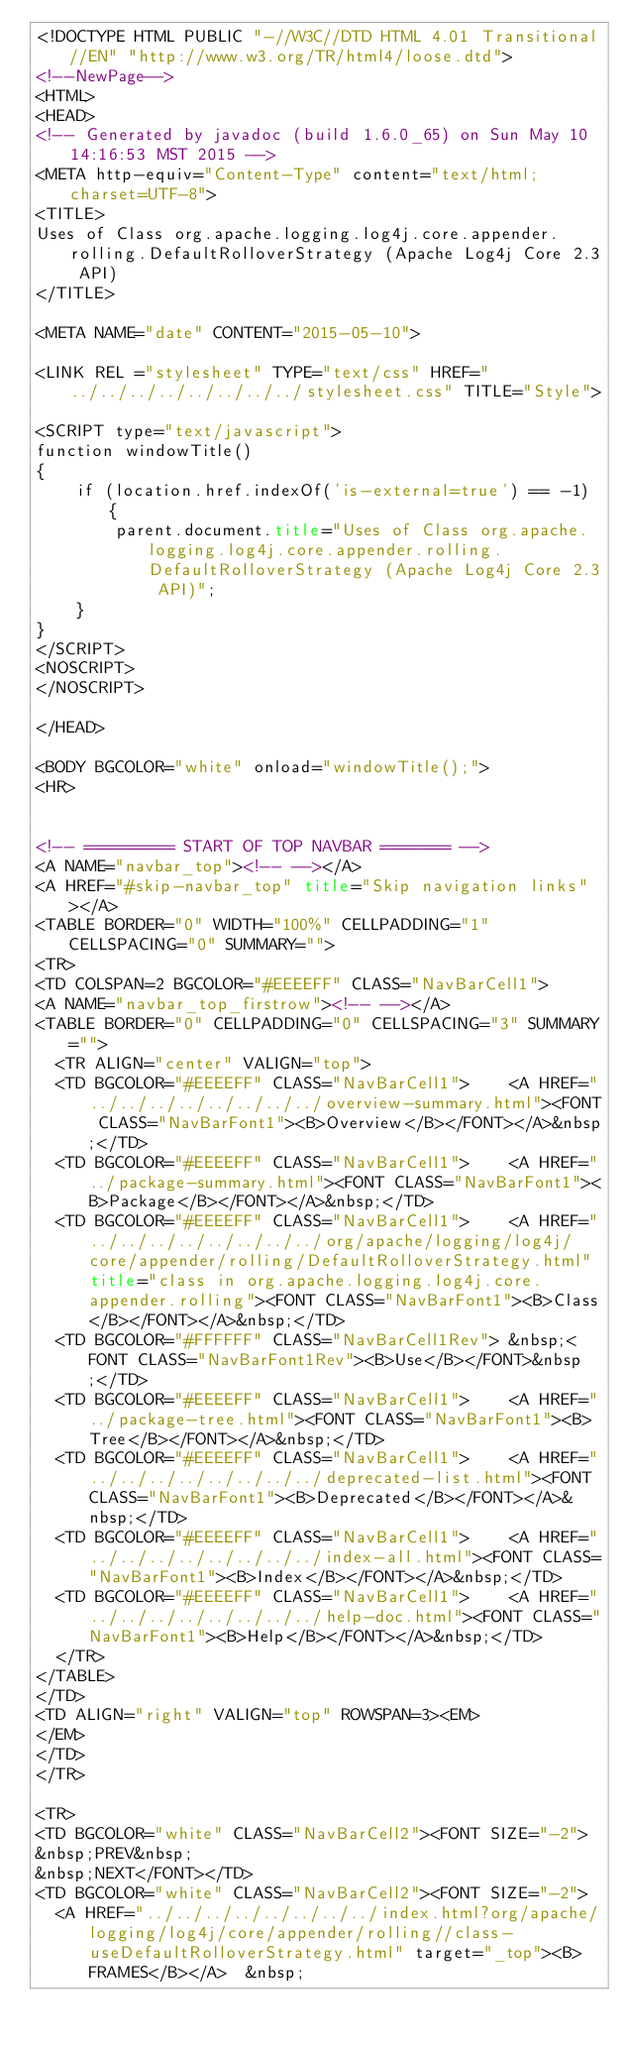<code> <loc_0><loc_0><loc_500><loc_500><_HTML_><!DOCTYPE HTML PUBLIC "-//W3C//DTD HTML 4.01 Transitional//EN" "http://www.w3.org/TR/html4/loose.dtd">
<!--NewPage-->
<HTML>
<HEAD>
<!-- Generated by javadoc (build 1.6.0_65) on Sun May 10 14:16:53 MST 2015 -->
<META http-equiv="Content-Type" content="text/html; charset=UTF-8">
<TITLE>
Uses of Class org.apache.logging.log4j.core.appender.rolling.DefaultRolloverStrategy (Apache Log4j Core 2.3 API)
</TITLE>

<META NAME="date" CONTENT="2015-05-10">

<LINK REL ="stylesheet" TYPE="text/css" HREF="../../../../../../../../stylesheet.css" TITLE="Style">

<SCRIPT type="text/javascript">
function windowTitle()
{
    if (location.href.indexOf('is-external=true') == -1) {
        parent.document.title="Uses of Class org.apache.logging.log4j.core.appender.rolling.DefaultRolloverStrategy (Apache Log4j Core 2.3 API)";
    }
}
</SCRIPT>
<NOSCRIPT>
</NOSCRIPT>

</HEAD>

<BODY BGCOLOR="white" onload="windowTitle();">
<HR>


<!-- ========= START OF TOP NAVBAR ======= -->
<A NAME="navbar_top"><!-- --></A>
<A HREF="#skip-navbar_top" title="Skip navigation links"></A>
<TABLE BORDER="0" WIDTH="100%" CELLPADDING="1" CELLSPACING="0" SUMMARY="">
<TR>
<TD COLSPAN=2 BGCOLOR="#EEEEFF" CLASS="NavBarCell1">
<A NAME="navbar_top_firstrow"><!-- --></A>
<TABLE BORDER="0" CELLPADDING="0" CELLSPACING="3" SUMMARY="">
  <TR ALIGN="center" VALIGN="top">
  <TD BGCOLOR="#EEEEFF" CLASS="NavBarCell1">    <A HREF="../../../../../../../../overview-summary.html"><FONT CLASS="NavBarFont1"><B>Overview</B></FONT></A>&nbsp;</TD>
  <TD BGCOLOR="#EEEEFF" CLASS="NavBarCell1">    <A HREF="../package-summary.html"><FONT CLASS="NavBarFont1"><B>Package</B></FONT></A>&nbsp;</TD>
  <TD BGCOLOR="#EEEEFF" CLASS="NavBarCell1">    <A HREF="../../../../../../../../org/apache/logging/log4j/core/appender/rolling/DefaultRolloverStrategy.html" title="class in org.apache.logging.log4j.core.appender.rolling"><FONT CLASS="NavBarFont1"><B>Class</B></FONT></A>&nbsp;</TD>
  <TD BGCOLOR="#FFFFFF" CLASS="NavBarCell1Rev"> &nbsp;<FONT CLASS="NavBarFont1Rev"><B>Use</B></FONT>&nbsp;</TD>
  <TD BGCOLOR="#EEEEFF" CLASS="NavBarCell1">    <A HREF="../package-tree.html"><FONT CLASS="NavBarFont1"><B>Tree</B></FONT></A>&nbsp;</TD>
  <TD BGCOLOR="#EEEEFF" CLASS="NavBarCell1">    <A HREF="../../../../../../../../deprecated-list.html"><FONT CLASS="NavBarFont1"><B>Deprecated</B></FONT></A>&nbsp;</TD>
  <TD BGCOLOR="#EEEEFF" CLASS="NavBarCell1">    <A HREF="../../../../../../../../index-all.html"><FONT CLASS="NavBarFont1"><B>Index</B></FONT></A>&nbsp;</TD>
  <TD BGCOLOR="#EEEEFF" CLASS="NavBarCell1">    <A HREF="../../../../../../../../help-doc.html"><FONT CLASS="NavBarFont1"><B>Help</B></FONT></A>&nbsp;</TD>
  </TR>
</TABLE>
</TD>
<TD ALIGN="right" VALIGN="top" ROWSPAN=3><EM>
</EM>
</TD>
</TR>

<TR>
<TD BGCOLOR="white" CLASS="NavBarCell2"><FONT SIZE="-2">
&nbsp;PREV&nbsp;
&nbsp;NEXT</FONT></TD>
<TD BGCOLOR="white" CLASS="NavBarCell2"><FONT SIZE="-2">
  <A HREF="../../../../../../../../index.html?org/apache/logging/log4j/core/appender/rolling//class-useDefaultRolloverStrategy.html" target="_top"><B>FRAMES</B></A>  &nbsp;</code> 